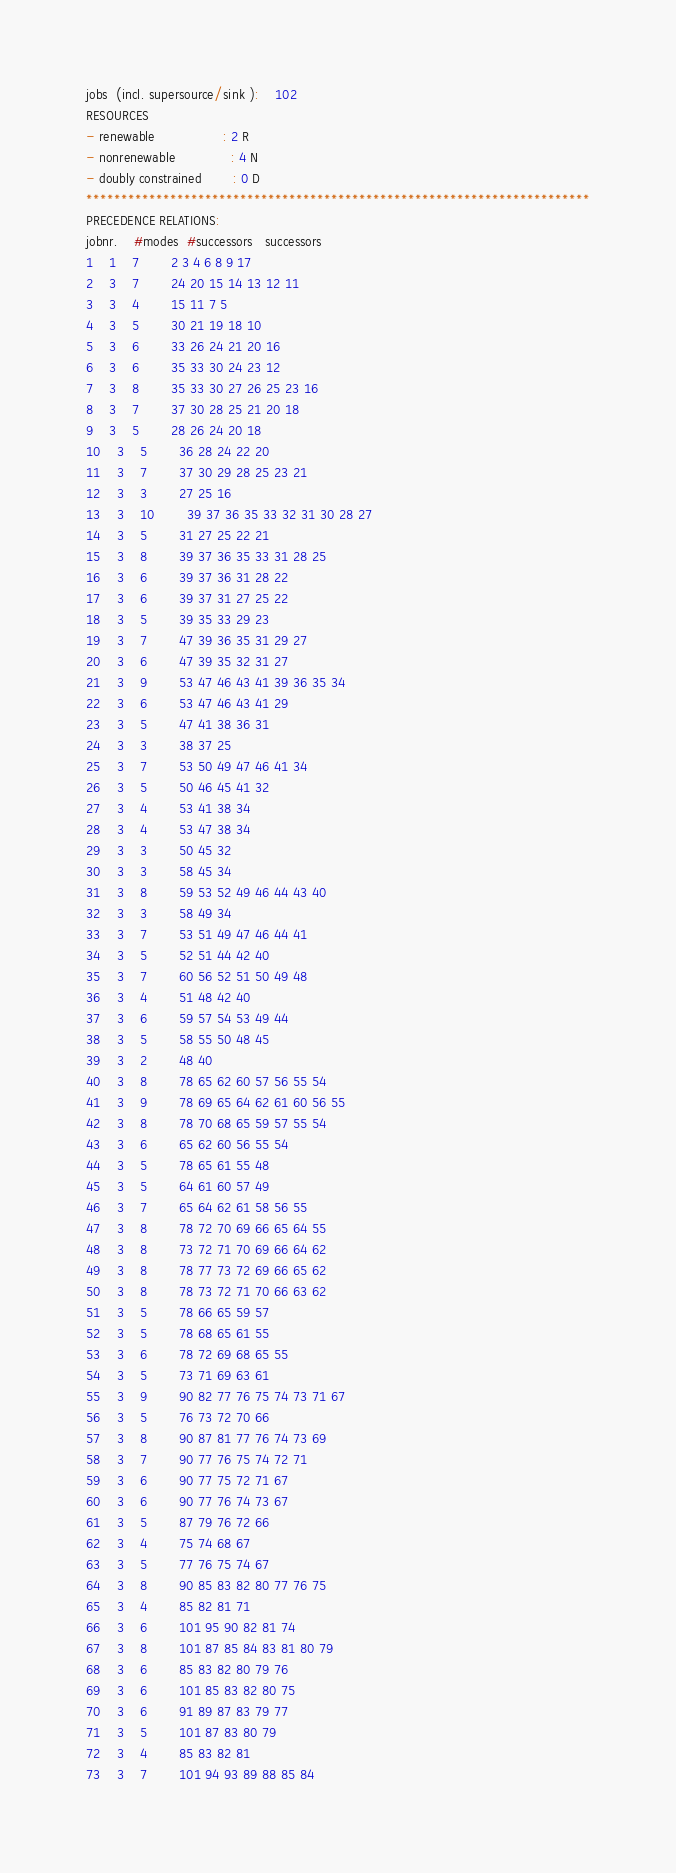<code> <loc_0><loc_0><loc_500><loc_500><_ObjectiveC_>jobs  (incl. supersource/sink ):	102
RESOURCES
- renewable                 : 2 R
- nonrenewable              : 4 N
- doubly constrained        : 0 D
************************************************************************
PRECEDENCE RELATIONS:
jobnr.    #modes  #successors   successors
1	1	7		2 3 4 6 8 9 17 
2	3	7		24 20 15 14 13 12 11 
3	3	4		15 11 7 5 
4	3	5		30 21 19 18 10 
5	3	6		33 26 24 21 20 16 
6	3	6		35 33 30 24 23 12 
7	3	8		35 33 30 27 26 25 23 16 
8	3	7		37 30 28 25 21 20 18 
9	3	5		28 26 24 20 18 
10	3	5		36 28 24 22 20 
11	3	7		37 30 29 28 25 23 21 
12	3	3		27 25 16 
13	3	10		39 37 36 35 33 32 31 30 28 27 
14	3	5		31 27 25 22 21 
15	3	8		39 37 36 35 33 31 28 25 
16	3	6		39 37 36 31 28 22 
17	3	6		39 37 31 27 25 22 
18	3	5		39 35 33 29 23 
19	3	7		47 39 36 35 31 29 27 
20	3	6		47 39 35 32 31 27 
21	3	9		53 47 46 43 41 39 36 35 34 
22	3	6		53 47 46 43 41 29 
23	3	5		47 41 38 36 31 
24	3	3		38 37 25 
25	3	7		53 50 49 47 46 41 34 
26	3	5		50 46 45 41 32 
27	3	4		53 41 38 34 
28	3	4		53 47 38 34 
29	3	3		50 45 32 
30	3	3		58 45 34 
31	3	8		59 53 52 49 46 44 43 40 
32	3	3		58 49 34 
33	3	7		53 51 49 47 46 44 41 
34	3	5		52 51 44 42 40 
35	3	7		60 56 52 51 50 49 48 
36	3	4		51 48 42 40 
37	3	6		59 57 54 53 49 44 
38	3	5		58 55 50 48 45 
39	3	2		48 40 
40	3	8		78 65 62 60 57 56 55 54 
41	3	9		78 69 65 64 62 61 60 56 55 
42	3	8		78 70 68 65 59 57 55 54 
43	3	6		65 62 60 56 55 54 
44	3	5		78 65 61 55 48 
45	3	5		64 61 60 57 49 
46	3	7		65 64 62 61 58 56 55 
47	3	8		78 72 70 69 66 65 64 55 
48	3	8		73 72 71 70 69 66 64 62 
49	3	8		78 77 73 72 69 66 65 62 
50	3	8		78 73 72 71 70 66 63 62 
51	3	5		78 66 65 59 57 
52	3	5		78 68 65 61 55 
53	3	6		78 72 69 68 65 55 
54	3	5		73 71 69 63 61 
55	3	9		90 82 77 76 75 74 73 71 67 
56	3	5		76 73 72 70 66 
57	3	8		90 87 81 77 76 74 73 69 
58	3	7		90 77 76 75 74 72 71 
59	3	6		90 77 75 72 71 67 
60	3	6		90 77 76 74 73 67 
61	3	5		87 79 76 72 66 
62	3	4		75 74 68 67 
63	3	5		77 76 75 74 67 
64	3	8		90 85 83 82 80 77 76 75 
65	3	4		85 82 81 71 
66	3	6		101 95 90 82 81 74 
67	3	8		101 87 85 84 83 81 80 79 
68	3	6		85 83 82 80 79 76 
69	3	6		101 85 83 82 80 75 
70	3	6		91 89 87 83 79 77 
71	3	5		101 87 83 80 79 
72	3	4		85 83 82 81 
73	3	7		101 94 93 89 88 85 84 </code> 